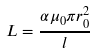Convert formula to latex. <formula><loc_0><loc_0><loc_500><loc_500>L = \frac { \alpha \mu _ { 0 } \pi r _ { 0 } ^ { 2 } } { l }</formula> 